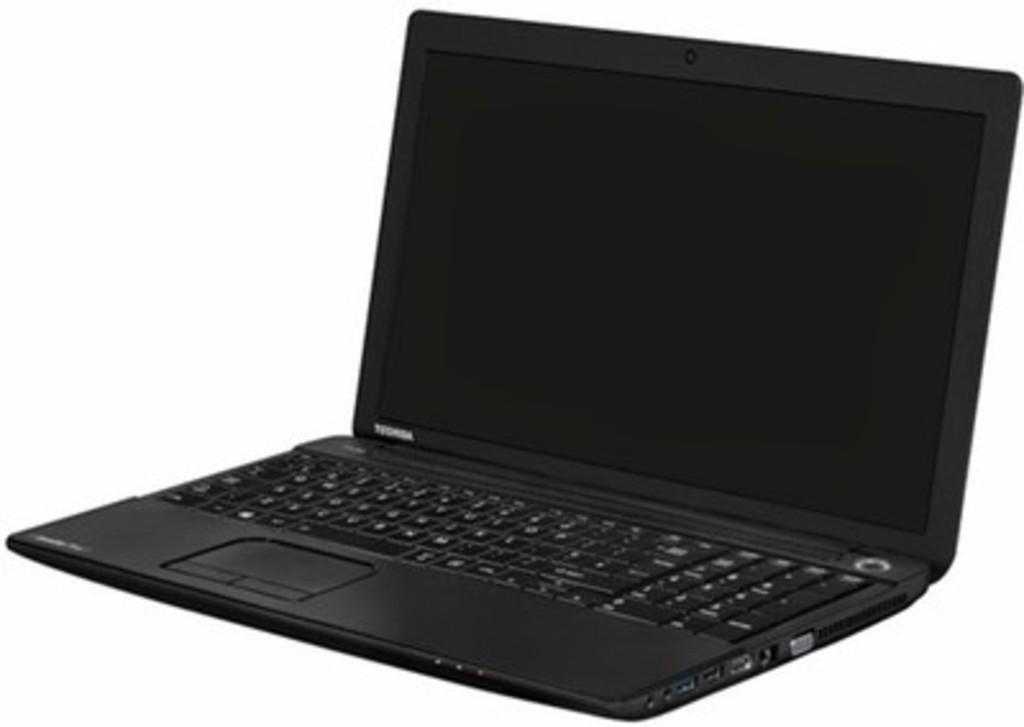<image>
Provide a brief description of the given image. A black laptop from the computer manufacturer Toshiba 